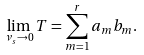Convert formula to latex. <formula><loc_0><loc_0><loc_500><loc_500>\lim _ { \nu _ { s } \rightarrow 0 } T = \sum _ { m = 1 } ^ { r } a _ { m } b _ { m } .</formula> 